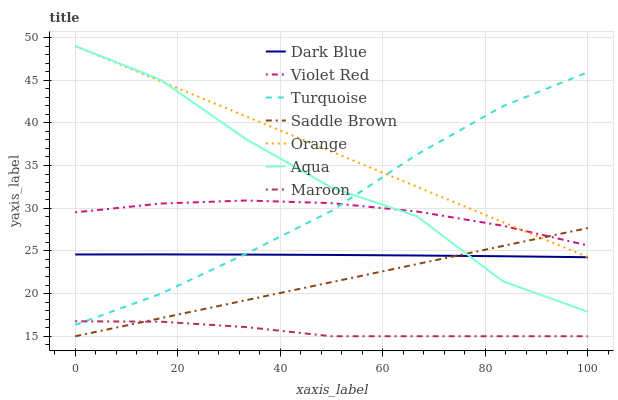Does Maroon have the minimum area under the curve?
Answer yes or no. Yes. Does Orange have the maximum area under the curve?
Answer yes or no. Yes. Does Aqua have the minimum area under the curve?
Answer yes or no. No. Does Aqua have the maximum area under the curve?
Answer yes or no. No. Is Orange the smoothest?
Answer yes or no. Yes. Is Aqua the roughest?
Answer yes or no. Yes. Is Turquoise the smoothest?
Answer yes or no. No. Is Turquoise the roughest?
Answer yes or no. No. Does Maroon have the lowest value?
Answer yes or no. Yes. Does Aqua have the lowest value?
Answer yes or no. No. Does Orange have the highest value?
Answer yes or no. Yes. Does Turquoise have the highest value?
Answer yes or no. No. Is Maroon less than Orange?
Answer yes or no. Yes. Is Turquoise greater than Saddle Brown?
Answer yes or no. Yes. Does Orange intersect Turquoise?
Answer yes or no. Yes. Is Orange less than Turquoise?
Answer yes or no. No. Is Orange greater than Turquoise?
Answer yes or no. No. Does Maroon intersect Orange?
Answer yes or no. No. 